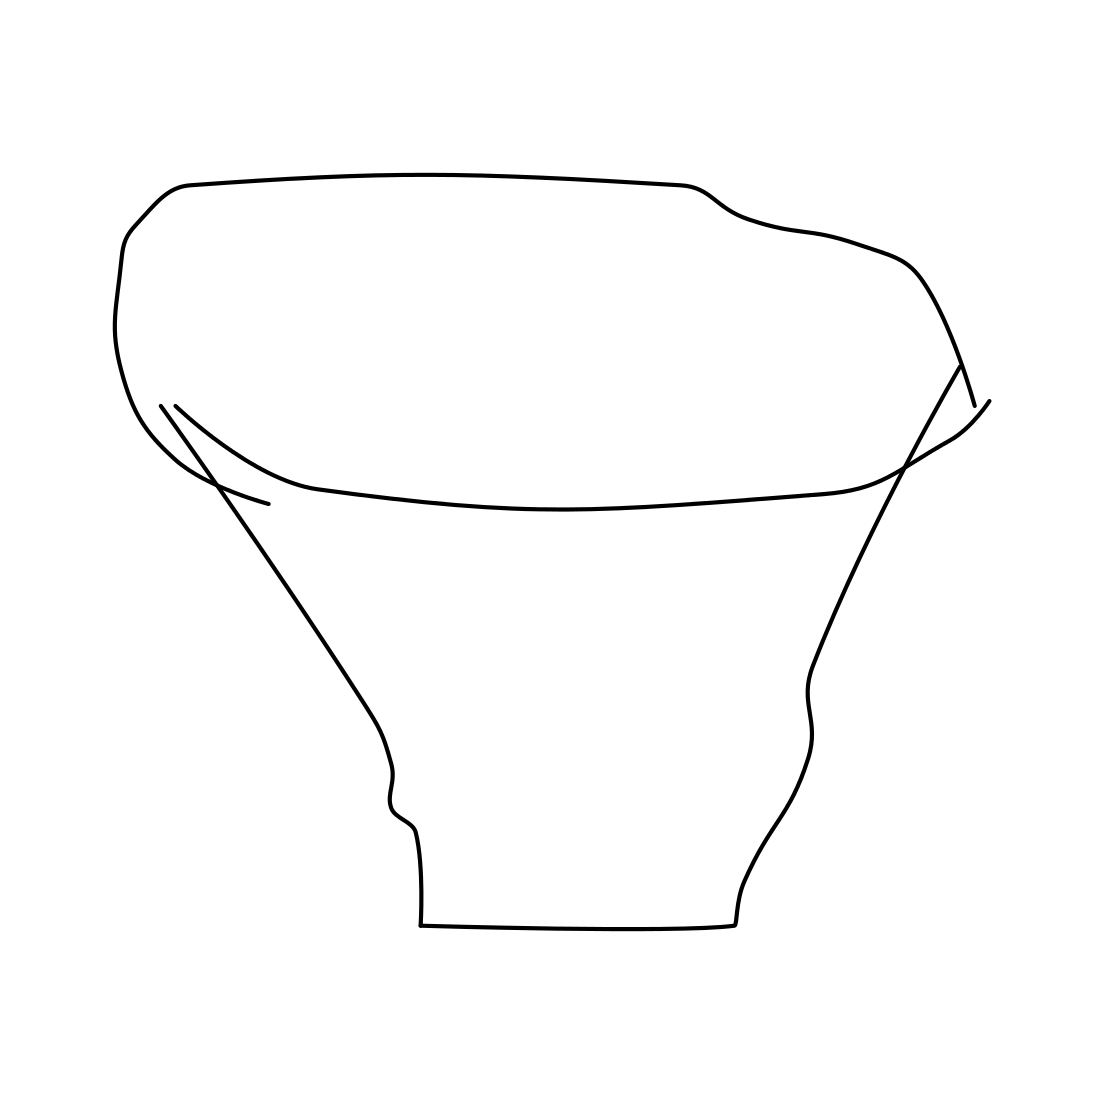In the scene, is an angel in it? No, there is no angel in the scene. The image shows a simple line drawing of what appears to be a pot or a container with no intricate patterns or additional elements that could suggest the presence of an angel or any other figure. 